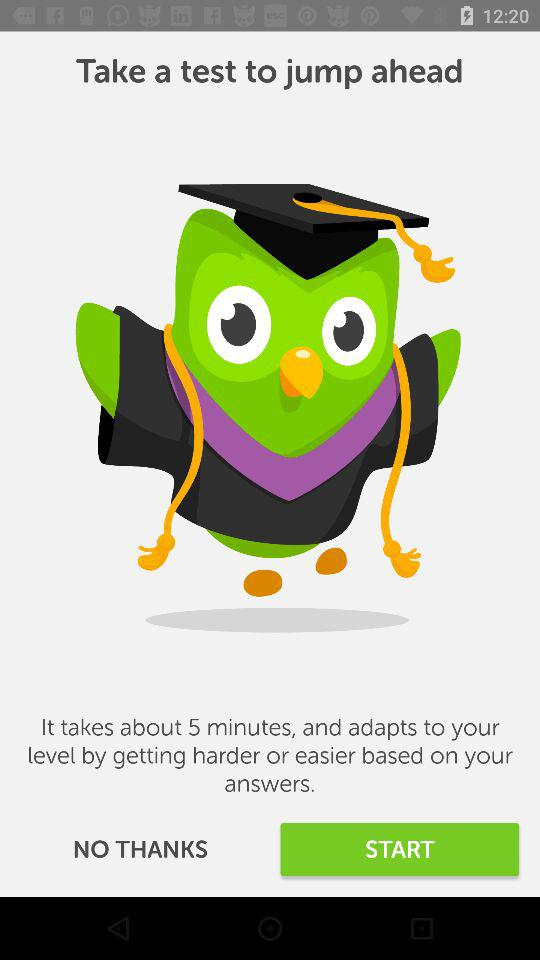How long will it take to adapt to next level?
When the provided information is insufficient, respond with <no answer>. <no answer> 